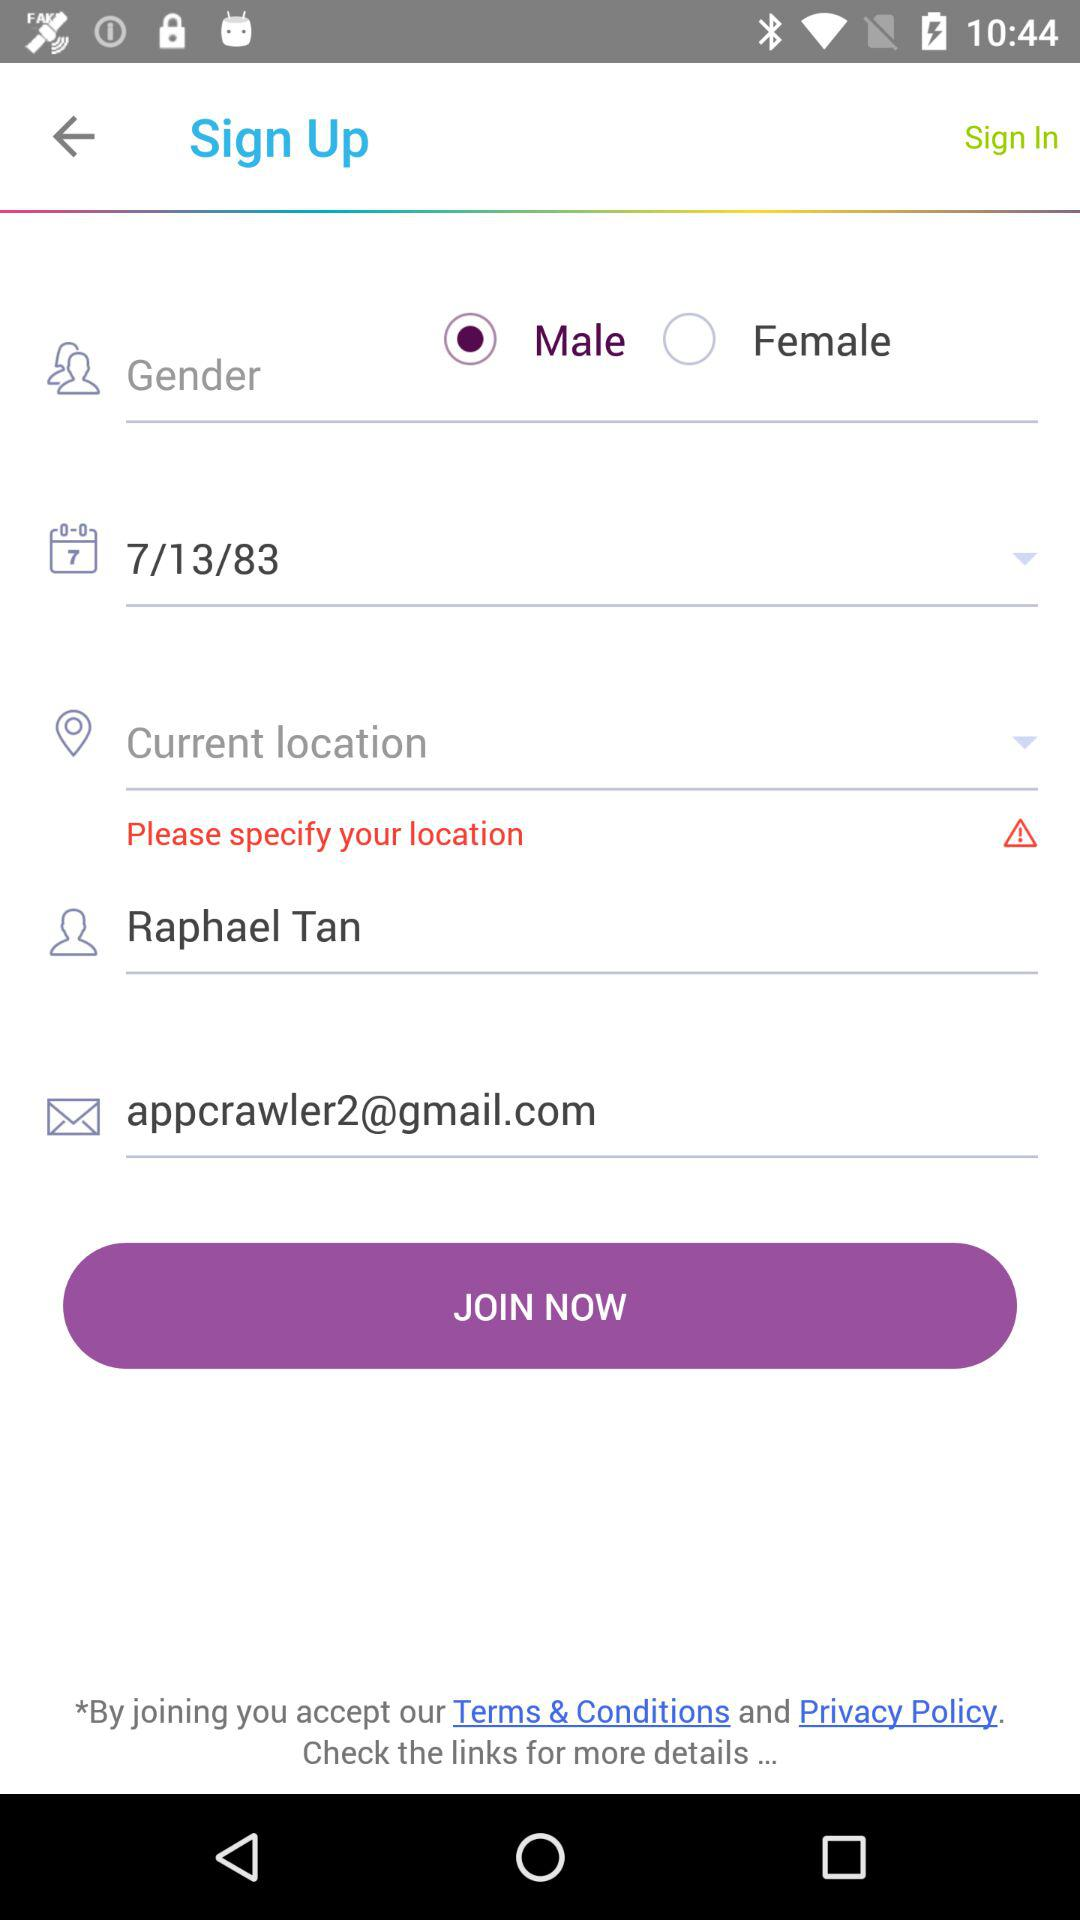What is the date of birth of the user? The date of birth of the user is July 13, 1983. 